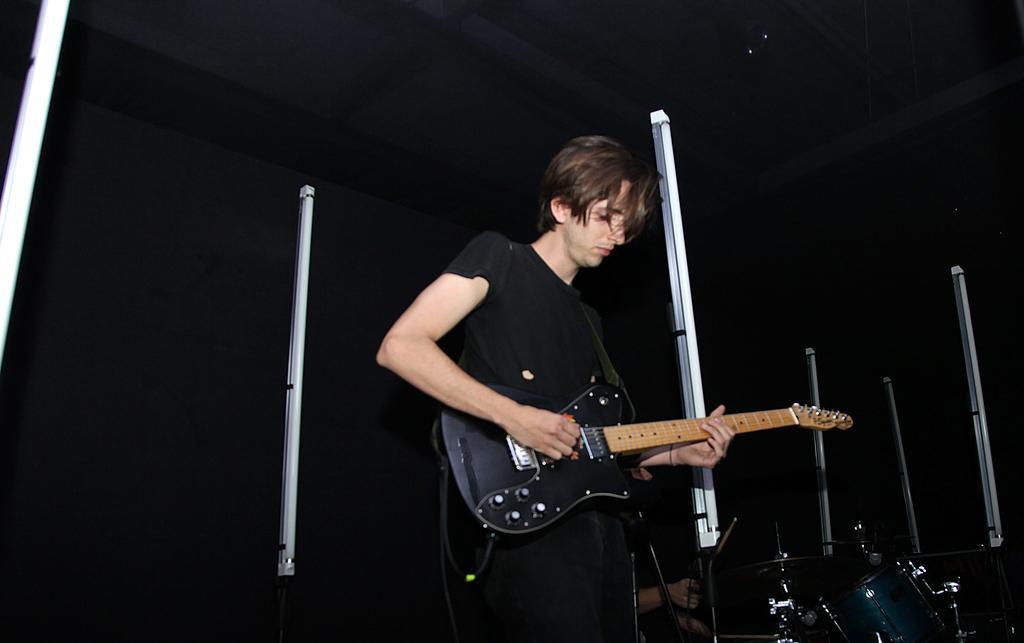Please provide a concise description of this image. There is a person in black color t-shirt, standing, holding and playing a guitar. Back to him, there is another person sitting and playing drums, near a tube lights, which are arranged vertically on the stage. The background is dark in color. 